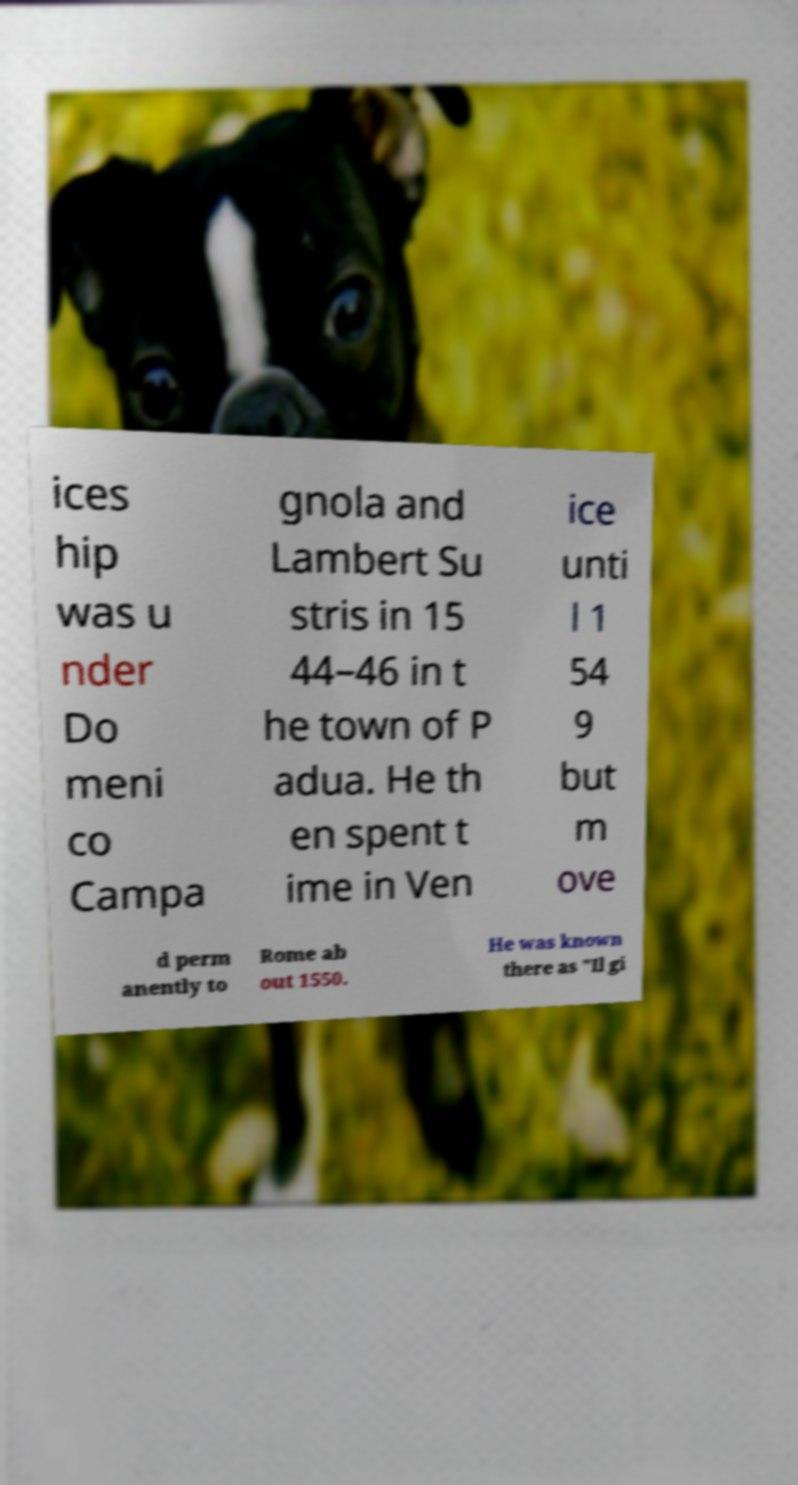Can you read and provide the text displayed in the image?This photo seems to have some interesting text. Can you extract and type it out for me? ices hip was u nder Do meni co Campa gnola and Lambert Su stris in 15 44–46 in t he town of P adua. He th en spent t ime in Ven ice unti l 1 54 9 but m ove d perm anently to Rome ab out 1550. He was known there as "Il gi 